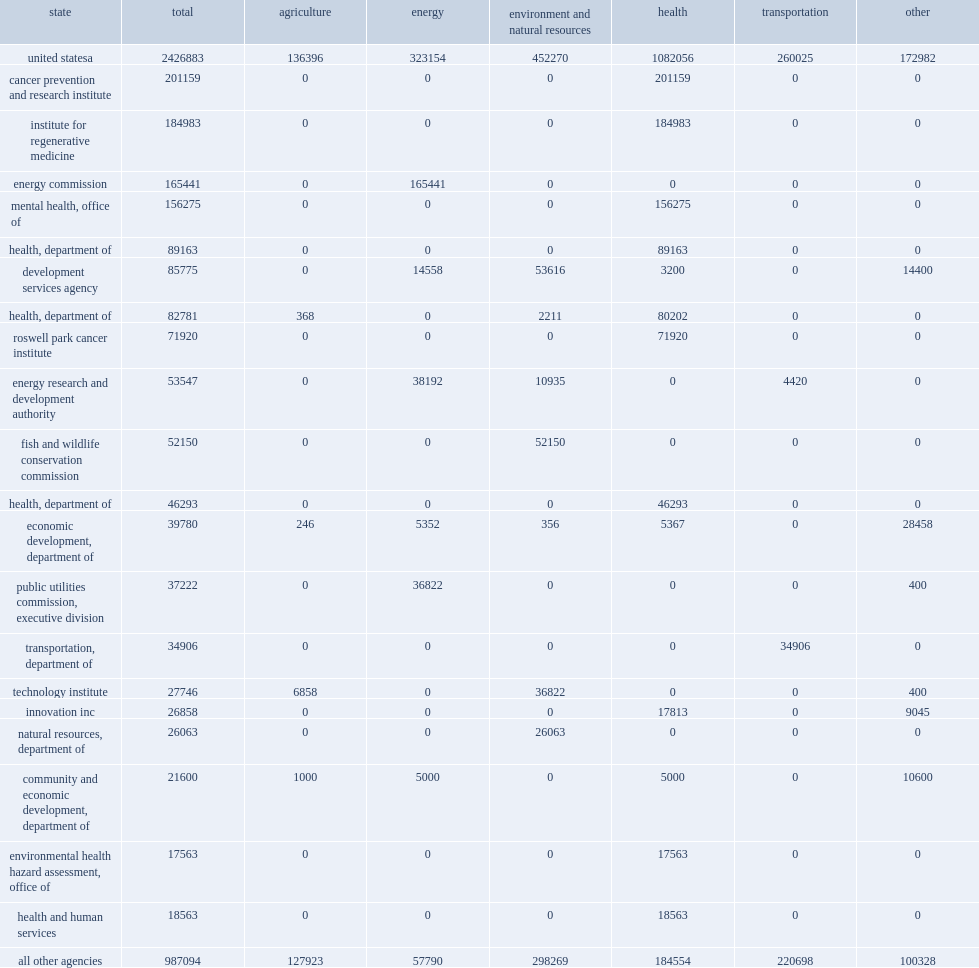How many thousand dollars in state agency health r&d? 1082056.0. 